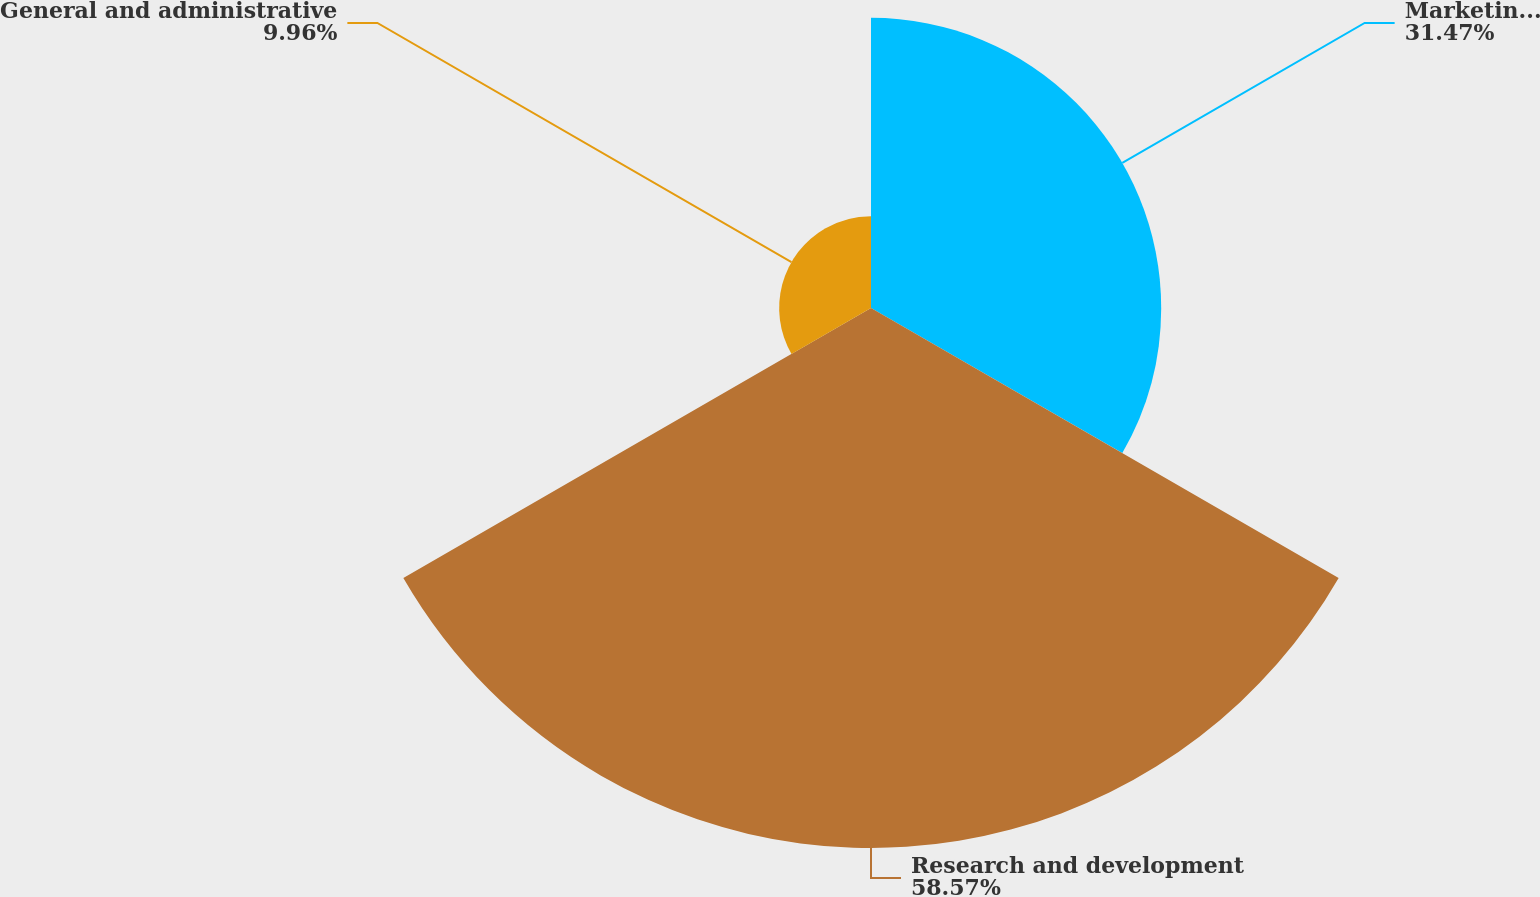Convert chart. <chart><loc_0><loc_0><loc_500><loc_500><pie_chart><fcel>Marketing and sales<fcel>Research and development<fcel>General and administrative<nl><fcel>31.47%<fcel>58.56%<fcel>9.96%<nl></chart> 